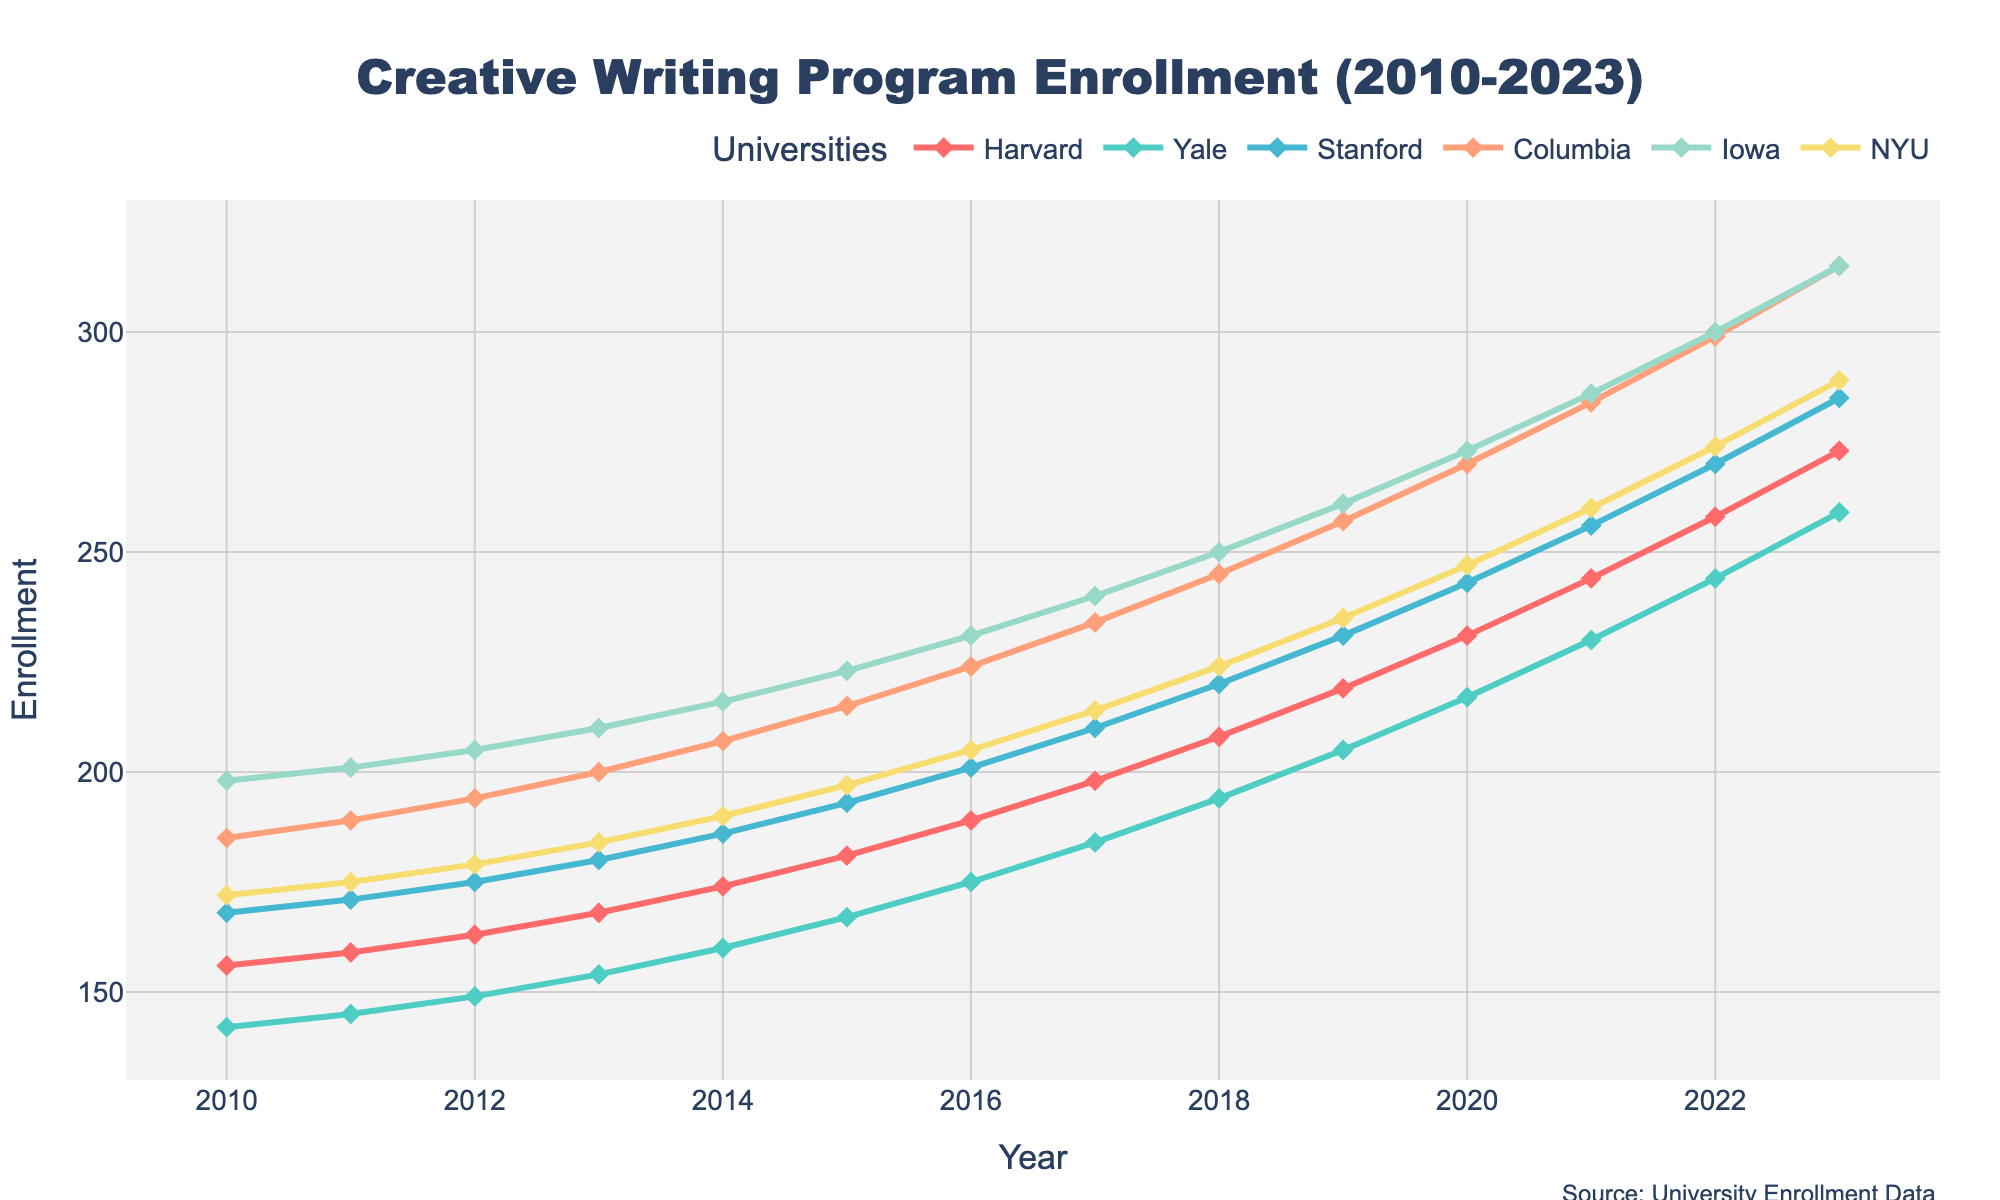Which university had the highest enrollment in 2023? Looking at the y-values for 2023 on the chart, Columbia and Iowa both reach the highest point, intersecting at the same enrollment value.
Answer: Columbia and Iowa What is the overall trend of enrollment for Harvard from 2010 to 2023? Observing the plot line for Harvard, the enrollment shows a consistent upward trend from 156 in 2010 to 273 in 2023.
Answer: Increasing Which university showed the most significant increase in enrollment between 2010 and 2023? Subtract the 2010 enrollment from the 2023 enrollment for each university and compare: Harvard (273-156), Yale (259-142), Stanford (285-168), Columbia (315-185), Iowa (315-198), NYU (289-172). Columbia shows the most significant increase.
Answer: Columbia In which year did NYU's enrollment surpass 200 for the first time? Trace NYU's plot line and identify the year when it first exceeds the 200 mark, which happens between 2015 and 2016, but specifically hits above 200 in 2016.
Answer: 2016 What is the average enrollment for Yale between 2010 and 2023? Calculate the average of Yale's enrollment from 2010 to 2023: (142+145+149+154+160+167+175+184+194+205+217+230+244+259)/14 = 191.64.
Answer: 191.64 By how much did Stanford's enrollment increase from 2012 to 2020? Subtract the 2012 enrollment for Stanford from the 2020 enrollment: 243 - 175 = 68.
Answer: 68 Which university had a steady increase in enrollment without any decrease across the years? Examine each university's plot line for consistent upward movement without any dips in values. Harvard shows steady growth every year.
Answer: Harvard How much higher was Columbia's enrollment than Yale's in 2023? Subtract Yale’s enrollment in 2023 from Columbia’s enrollment in the same year: 315 - 259 = 56.
Answer: 56 Which university's enrollment lines intersect in 2023? Observe the focal points where two enrollment lines cross each other in 2023. Columbia and Iowa intersect.
Answer: Columbia and Iowa What can be inferred about the trend in the popularity of creative writing programs overall between 2010 and 2023? All the universities' enrollment lines exhibit an upward trend, indicating increasing popularity and demand for creative writing programs over the years.
Answer: Increasing popularity 